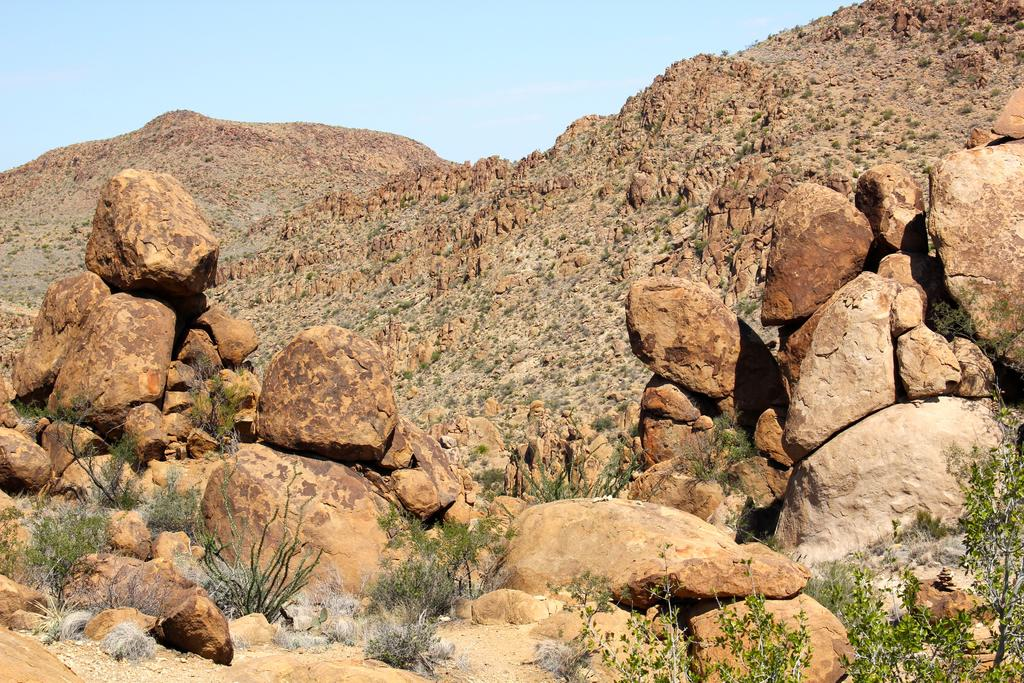What type of living organisms can be seen in the image? Plants can be seen in the image. What type of geological formations are present in the image? There are rocks and hills in the image. What part of the natural environment is visible in the image? The sky is visible in the image. What type of bit can be seen in the image? There is no bit present in the image. What type of riddle can be solved using the image? There is no riddle present in the image. 